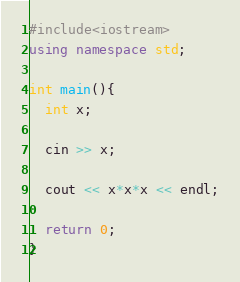Convert code to text. <code><loc_0><loc_0><loc_500><loc_500><_C++_>#include<iostream>
using namespace std;
 
int main(){
  int x;

  cin >> x;

  cout << x*x*x << endl;

  return 0;		 
}
</code> 